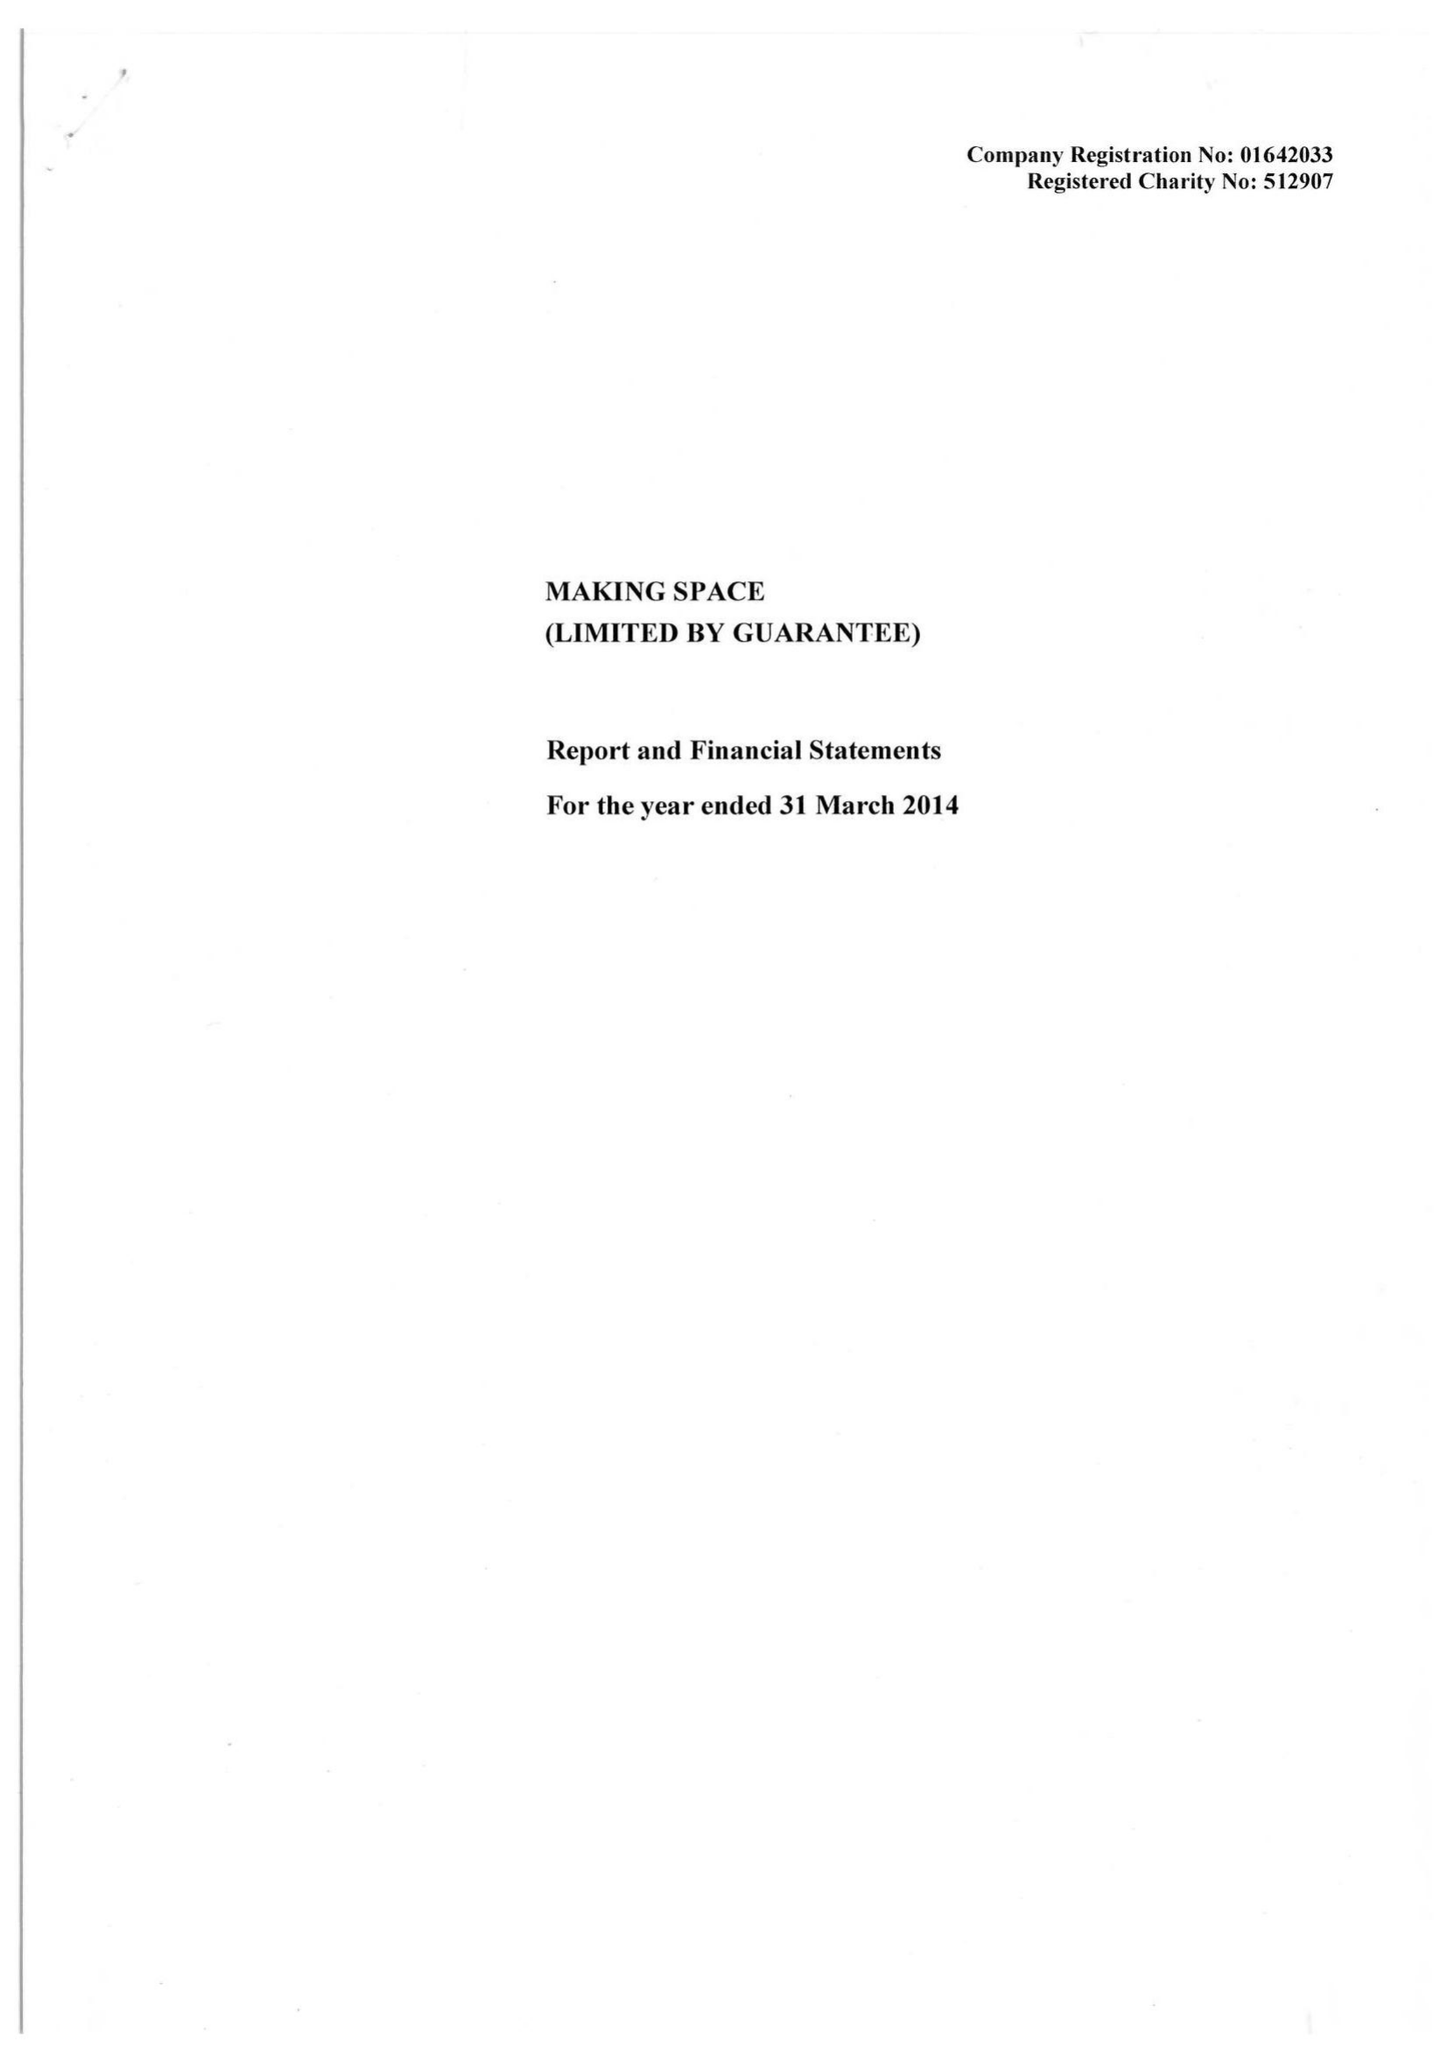What is the value for the charity_number?
Answer the question using a single word or phrase. 512907 